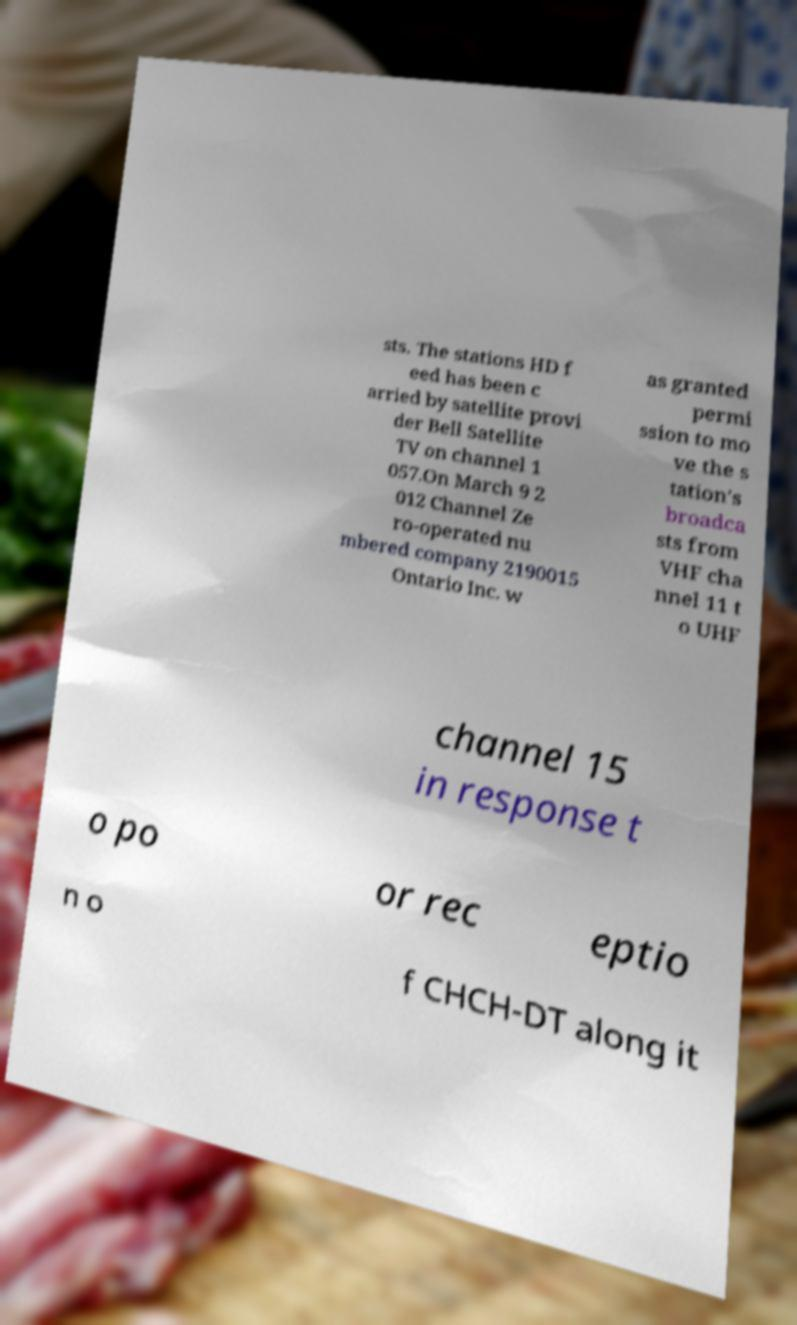I need the written content from this picture converted into text. Can you do that? sts. The stations HD f eed has been c arried by satellite provi der Bell Satellite TV on channel 1 057.On March 9 2 012 Channel Ze ro-operated nu mbered company 2190015 Ontario Inc. w as granted permi ssion to mo ve the s tation's broadca sts from VHF cha nnel 11 t o UHF channel 15 in response t o po or rec eptio n o f CHCH-DT along it 